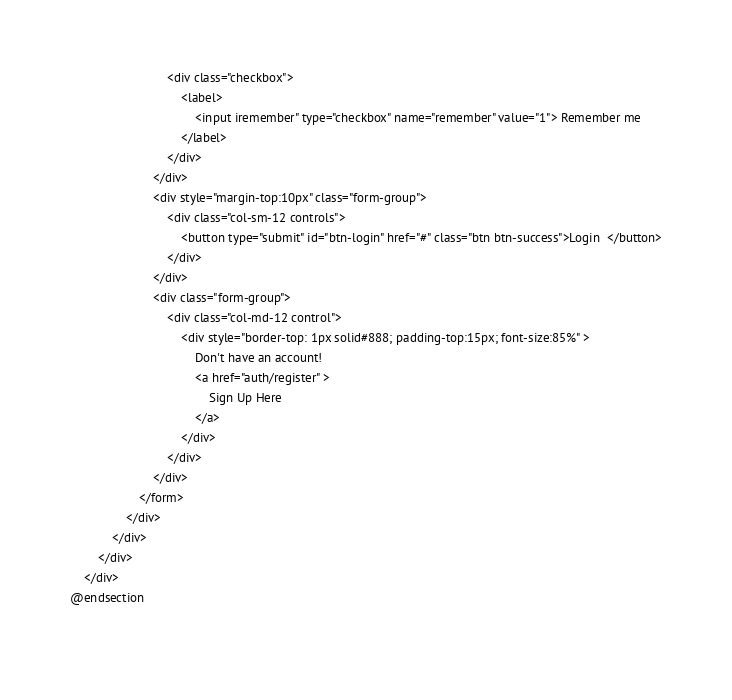Convert code to text. <code><loc_0><loc_0><loc_500><loc_500><_PHP_>                            <div class="checkbox">
                                <label>
                                    <input iremember" type="checkbox" name="remember" value="1"> Remember me
                                </label>
                            </div>
                        </div>
                        <div style="margin-top:10px" class="form-group">
                            <div class="col-sm-12 controls">
                                <button type="submit" id="btn-login" href="#" class="btn btn-success">Login  </button>
                            </div>
                        </div>
                        <div class="form-group">
                            <div class="col-md-12 control">
                                <div style="border-top: 1px solid#888; padding-top:15px; font-size:85%" >
                                    Don't have an account!
                                    <a href="auth/register" >
                                        Sign Up Here
                                    </a>
                                </div>
                            </div>
                        </div>
                    </form>
                </div>
            </div>
        </div>
    </div>
@endsection
 </code> 